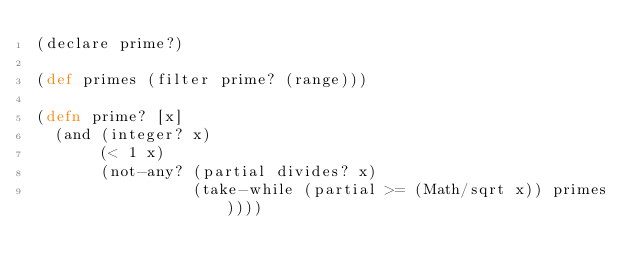Convert code to text. <code><loc_0><loc_0><loc_500><loc_500><_Clojure_>(declare prime?)

(def primes (filter prime? (range)))

(defn prime? [x]
  (and (integer? x)
       (< 1 x)
       (not-any? (partial divides? x)
                 (take-while (partial >= (Math/sqrt x)) primes))))
</code> 